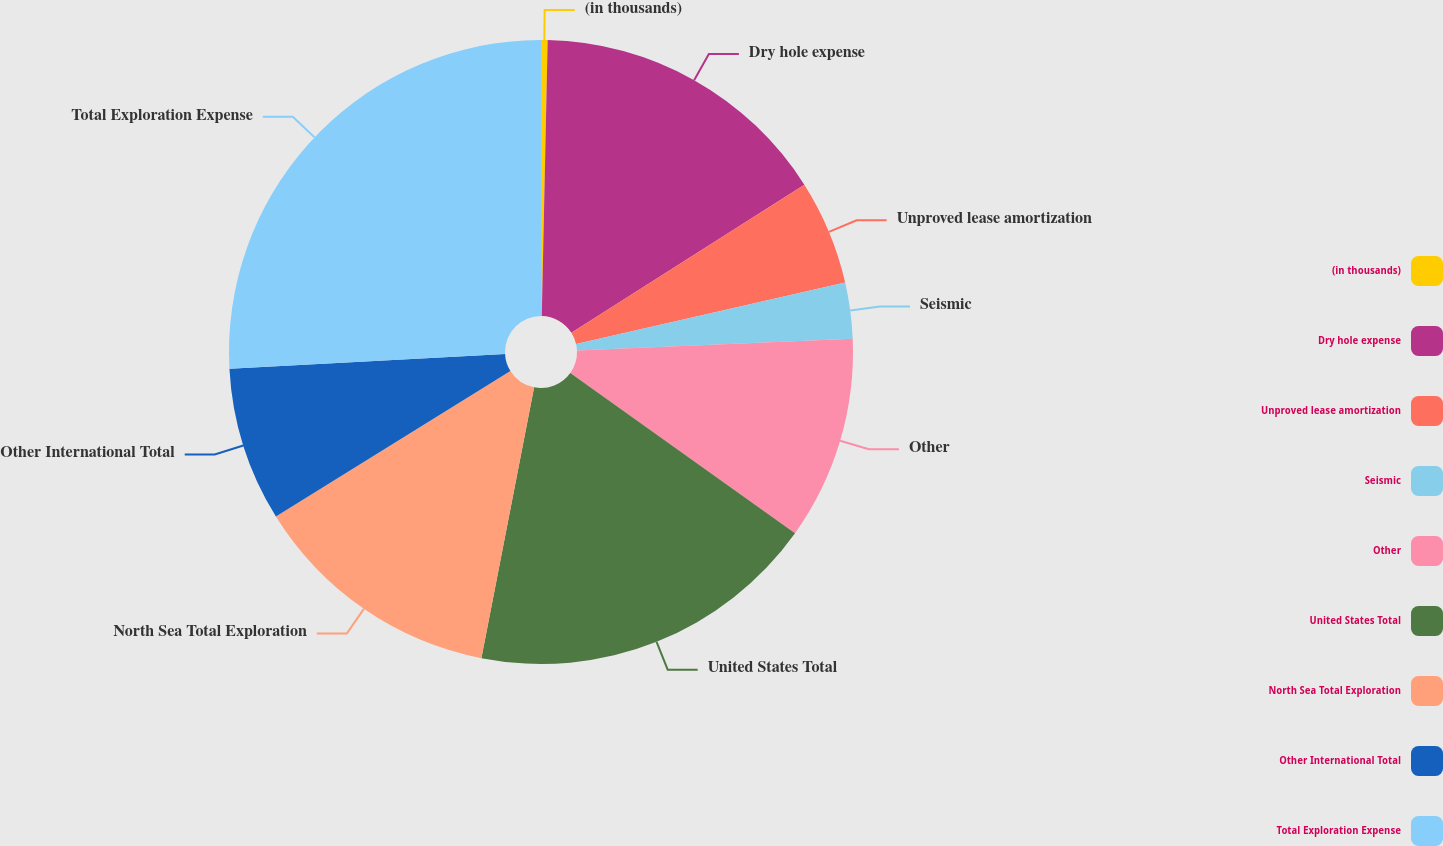Convert chart to OTSL. <chart><loc_0><loc_0><loc_500><loc_500><pie_chart><fcel>(in thousands)<fcel>Dry hole expense<fcel>Unproved lease amortization<fcel>Seismic<fcel>Other<fcel>United States Total<fcel>North Sea Total Exploration<fcel>Other International Total<fcel>Total Exploration Expense<nl><fcel>0.34%<fcel>15.65%<fcel>5.44%<fcel>2.89%<fcel>10.54%<fcel>18.2%<fcel>13.1%<fcel>7.99%<fcel>25.85%<nl></chart> 